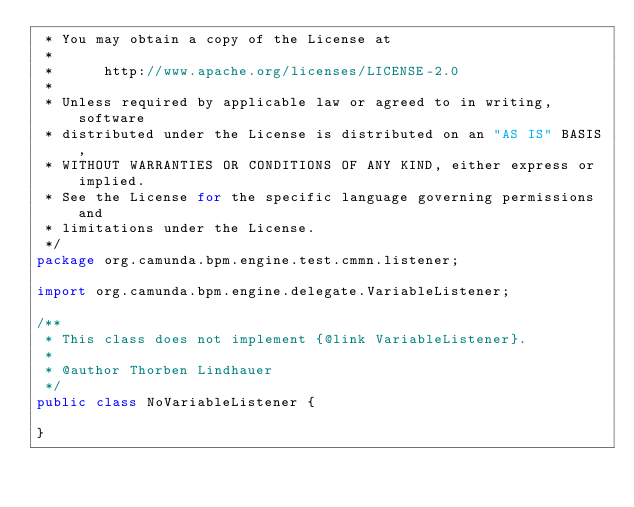<code> <loc_0><loc_0><loc_500><loc_500><_Java_> * You may obtain a copy of the License at
 *
 *      http://www.apache.org/licenses/LICENSE-2.0
 *
 * Unless required by applicable law or agreed to in writing, software
 * distributed under the License is distributed on an "AS IS" BASIS,
 * WITHOUT WARRANTIES OR CONDITIONS OF ANY KIND, either express or implied.
 * See the License for the specific language governing permissions and
 * limitations under the License.
 */
package org.camunda.bpm.engine.test.cmmn.listener;

import org.camunda.bpm.engine.delegate.VariableListener;

/**
 * This class does not implement {@link VariableListener}.
 *
 * @author Thorben Lindhauer
 */
public class NoVariableListener {

}
</code> 